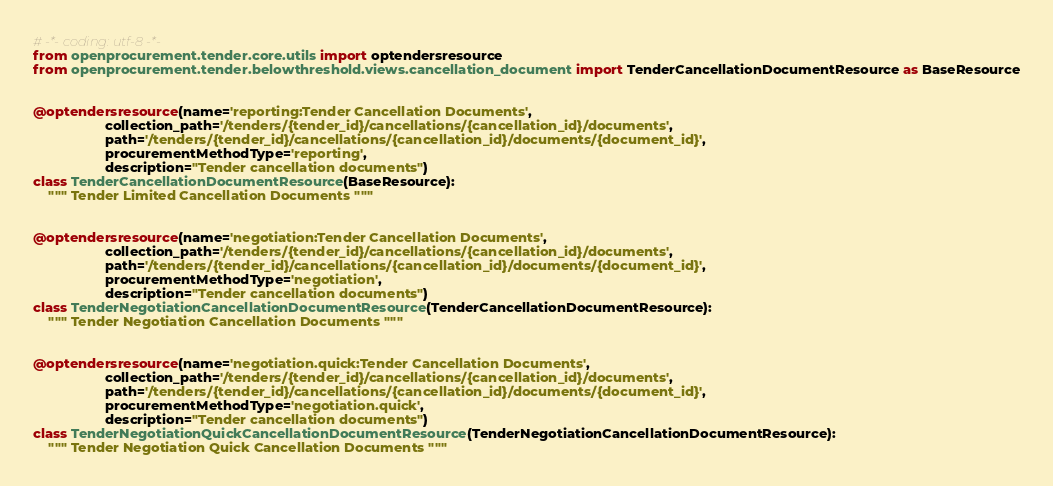<code> <loc_0><loc_0><loc_500><loc_500><_Python_># -*- coding: utf-8 -*-
from openprocurement.tender.core.utils import optendersresource
from openprocurement.tender.belowthreshold.views.cancellation_document import TenderCancellationDocumentResource as BaseResource


@optendersresource(name='reporting:Tender Cancellation Documents',
                   collection_path='/tenders/{tender_id}/cancellations/{cancellation_id}/documents',
                   path='/tenders/{tender_id}/cancellations/{cancellation_id}/documents/{document_id}',
                   procurementMethodType='reporting',
                   description="Tender cancellation documents")
class TenderCancellationDocumentResource(BaseResource):
    """ Tender Limited Cancellation Documents """


@optendersresource(name='negotiation:Tender Cancellation Documents',
                   collection_path='/tenders/{tender_id}/cancellations/{cancellation_id}/documents',
                   path='/tenders/{tender_id}/cancellations/{cancellation_id}/documents/{document_id}',
                   procurementMethodType='negotiation',
                   description="Tender cancellation documents")
class TenderNegotiationCancellationDocumentResource(TenderCancellationDocumentResource):
    """ Tender Negotiation Cancellation Documents """


@optendersresource(name='negotiation.quick:Tender Cancellation Documents',
                   collection_path='/tenders/{tender_id}/cancellations/{cancellation_id}/documents',
                   path='/tenders/{tender_id}/cancellations/{cancellation_id}/documents/{document_id}',
                   procurementMethodType='negotiation.quick',
                   description="Tender cancellation documents")
class TenderNegotiationQuickCancellationDocumentResource(TenderNegotiationCancellationDocumentResource):
    """ Tender Negotiation Quick Cancellation Documents """
</code> 